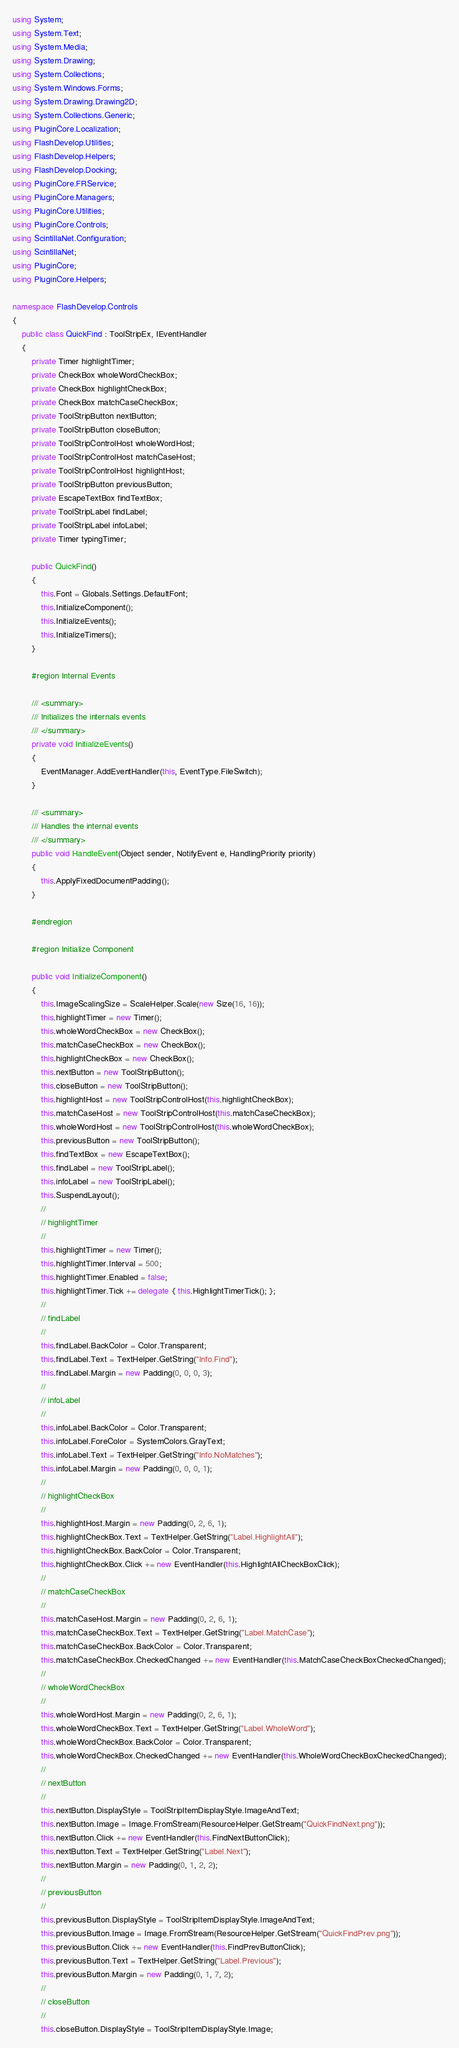<code> <loc_0><loc_0><loc_500><loc_500><_C#_>using System;
using System.Text;
using System.Media;
using System.Drawing;
using System.Collections;
using System.Windows.Forms;
using System.Drawing.Drawing2D;
using System.Collections.Generic;
using PluginCore.Localization;
using FlashDevelop.Utilities;
using FlashDevelop.Helpers;
using FlashDevelop.Docking;
using PluginCore.FRService;
using PluginCore.Managers;
using PluginCore.Utilities;
using PluginCore.Controls;
using ScintillaNet.Configuration;
using ScintillaNet;
using PluginCore;
using PluginCore.Helpers;

namespace FlashDevelop.Controls
{
    public class QuickFind : ToolStripEx, IEventHandler
    {
        private Timer highlightTimer;
        private CheckBox wholeWordCheckBox;
        private CheckBox highlightCheckBox;
        private CheckBox matchCaseCheckBox;
        private ToolStripButton nextButton;
        private ToolStripButton closeButton;
        private ToolStripControlHost wholeWordHost;
        private ToolStripControlHost matchCaseHost;
        private ToolStripControlHost highlightHost;
        private ToolStripButton previousButton;
        private EscapeTextBox findTextBox;
        private ToolStripLabel findLabel;
        private ToolStripLabel infoLabel;
        private Timer typingTimer;

        public QuickFind()
        {
            this.Font = Globals.Settings.DefaultFont;
            this.InitializeComponent();
            this.InitializeEvents();
            this.InitializeTimers();
        }

        #region Internal Events

        /// <summary>
        /// Initializes the internals events
        /// </summary>
        private void InitializeEvents()
        {
            EventManager.AddEventHandler(this, EventType.FileSwitch);
        }

        /// <summary>
        /// Handles the internal events
        /// </summary>
        public void HandleEvent(Object sender, NotifyEvent e, HandlingPriority priority)
        {
            this.ApplyFixedDocumentPadding();
        }

        #endregion

        #region Initialize Component

        public void InitializeComponent()
        {
            this.ImageScalingSize = ScaleHelper.Scale(new Size(16, 16));
            this.highlightTimer = new Timer();
            this.wholeWordCheckBox = new CheckBox();
            this.matchCaseCheckBox = new CheckBox();
            this.highlightCheckBox = new CheckBox();
            this.nextButton = new ToolStripButton();
            this.closeButton = new ToolStripButton();
            this.highlightHost = new ToolStripControlHost(this.highlightCheckBox);
            this.matchCaseHost = new ToolStripControlHost(this.matchCaseCheckBox);
            this.wholeWordHost = new ToolStripControlHost(this.wholeWordCheckBox);
            this.previousButton = new ToolStripButton();
            this.findTextBox = new EscapeTextBox();
            this.findLabel = new ToolStripLabel();
            this.infoLabel = new ToolStripLabel();
            this.SuspendLayout();
            //
            // highlightTimer
            //
            this.highlightTimer = new Timer();
            this.highlightTimer.Interval = 500;
            this.highlightTimer.Enabled = false;
            this.highlightTimer.Tick += delegate { this.HighlightTimerTick(); };
            //
            // findLabel
            //
            this.findLabel.BackColor = Color.Transparent;
            this.findLabel.Text = TextHelper.GetString("Info.Find");
            this.findLabel.Margin = new Padding(0, 0, 0, 3);
            //
            // infoLabel
            //
            this.infoLabel.BackColor = Color.Transparent;
            this.infoLabel.ForeColor = SystemColors.GrayText;
            this.infoLabel.Text = TextHelper.GetString("Info.NoMatches");
            this.infoLabel.Margin = new Padding(0, 0, 0, 1);
            //
            // highlightCheckBox
            //
            this.highlightHost.Margin = new Padding(0, 2, 6, 1);
            this.highlightCheckBox.Text = TextHelper.GetString("Label.HighlightAll");
            this.highlightCheckBox.BackColor = Color.Transparent;
            this.highlightCheckBox.Click += new EventHandler(this.HighlightAllCheckBoxClick);
            //
            // matchCaseCheckBox
            //
            this.matchCaseHost.Margin = new Padding(0, 2, 6, 1);
            this.matchCaseCheckBox.Text = TextHelper.GetString("Label.MatchCase");
            this.matchCaseCheckBox.BackColor = Color.Transparent;
            this.matchCaseCheckBox.CheckedChanged += new EventHandler(this.MatchCaseCheckBoxCheckedChanged);
            //
            // wholeWordCheckBox
            //
            this.wholeWordHost.Margin = new Padding(0, 2, 6, 1);
            this.wholeWordCheckBox.Text = TextHelper.GetString("Label.WholeWord");
            this.wholeWordCheckBox.BackColor = Color.Transparent;
            this.wholeWordCheckBox.CheckedChanged += new EventHandler(this.WholeWordCheckBoxCheckedChanged);
            //
            // nextButton
            //
            this.nextButton.DisplayStyle = ToolStripItemDisplayStyle.ImageAndText;
            this.nextButton.Image = Image.FromStream(ResourceHelper.GetStream("QuickFindNext.png"));
            this.nextButton.Click += new EventHandler(this.FindNextButtonClick);
            this.nextButton.Text = TextHelper.GetString("Label.Next");
            this.nextButton.Margin = new Padding(0, 1, 2, 2);
            //
            // previousButton
            //
            this.previousButton.DisplayStyle = ToolStripItemDisplayStyle.ImageAndText;
            this.previousButton.Image = Image.FromStream(ResourceHelper.GetStream("QuickFindPrev.png"));
            this.previousButton.Click += new EventHandler(this.FindPrevButtonClick);
            this.previousButton.Text = TextHelper.GetString("Label.Previous");
            this.previousButton.Margin = new Padding(0, 1, 7, 2);
            //
            // closeButton
            //
            this.closeButton.DisplayStyle = ToolStripItemDisplayStyle.Image;</code> 